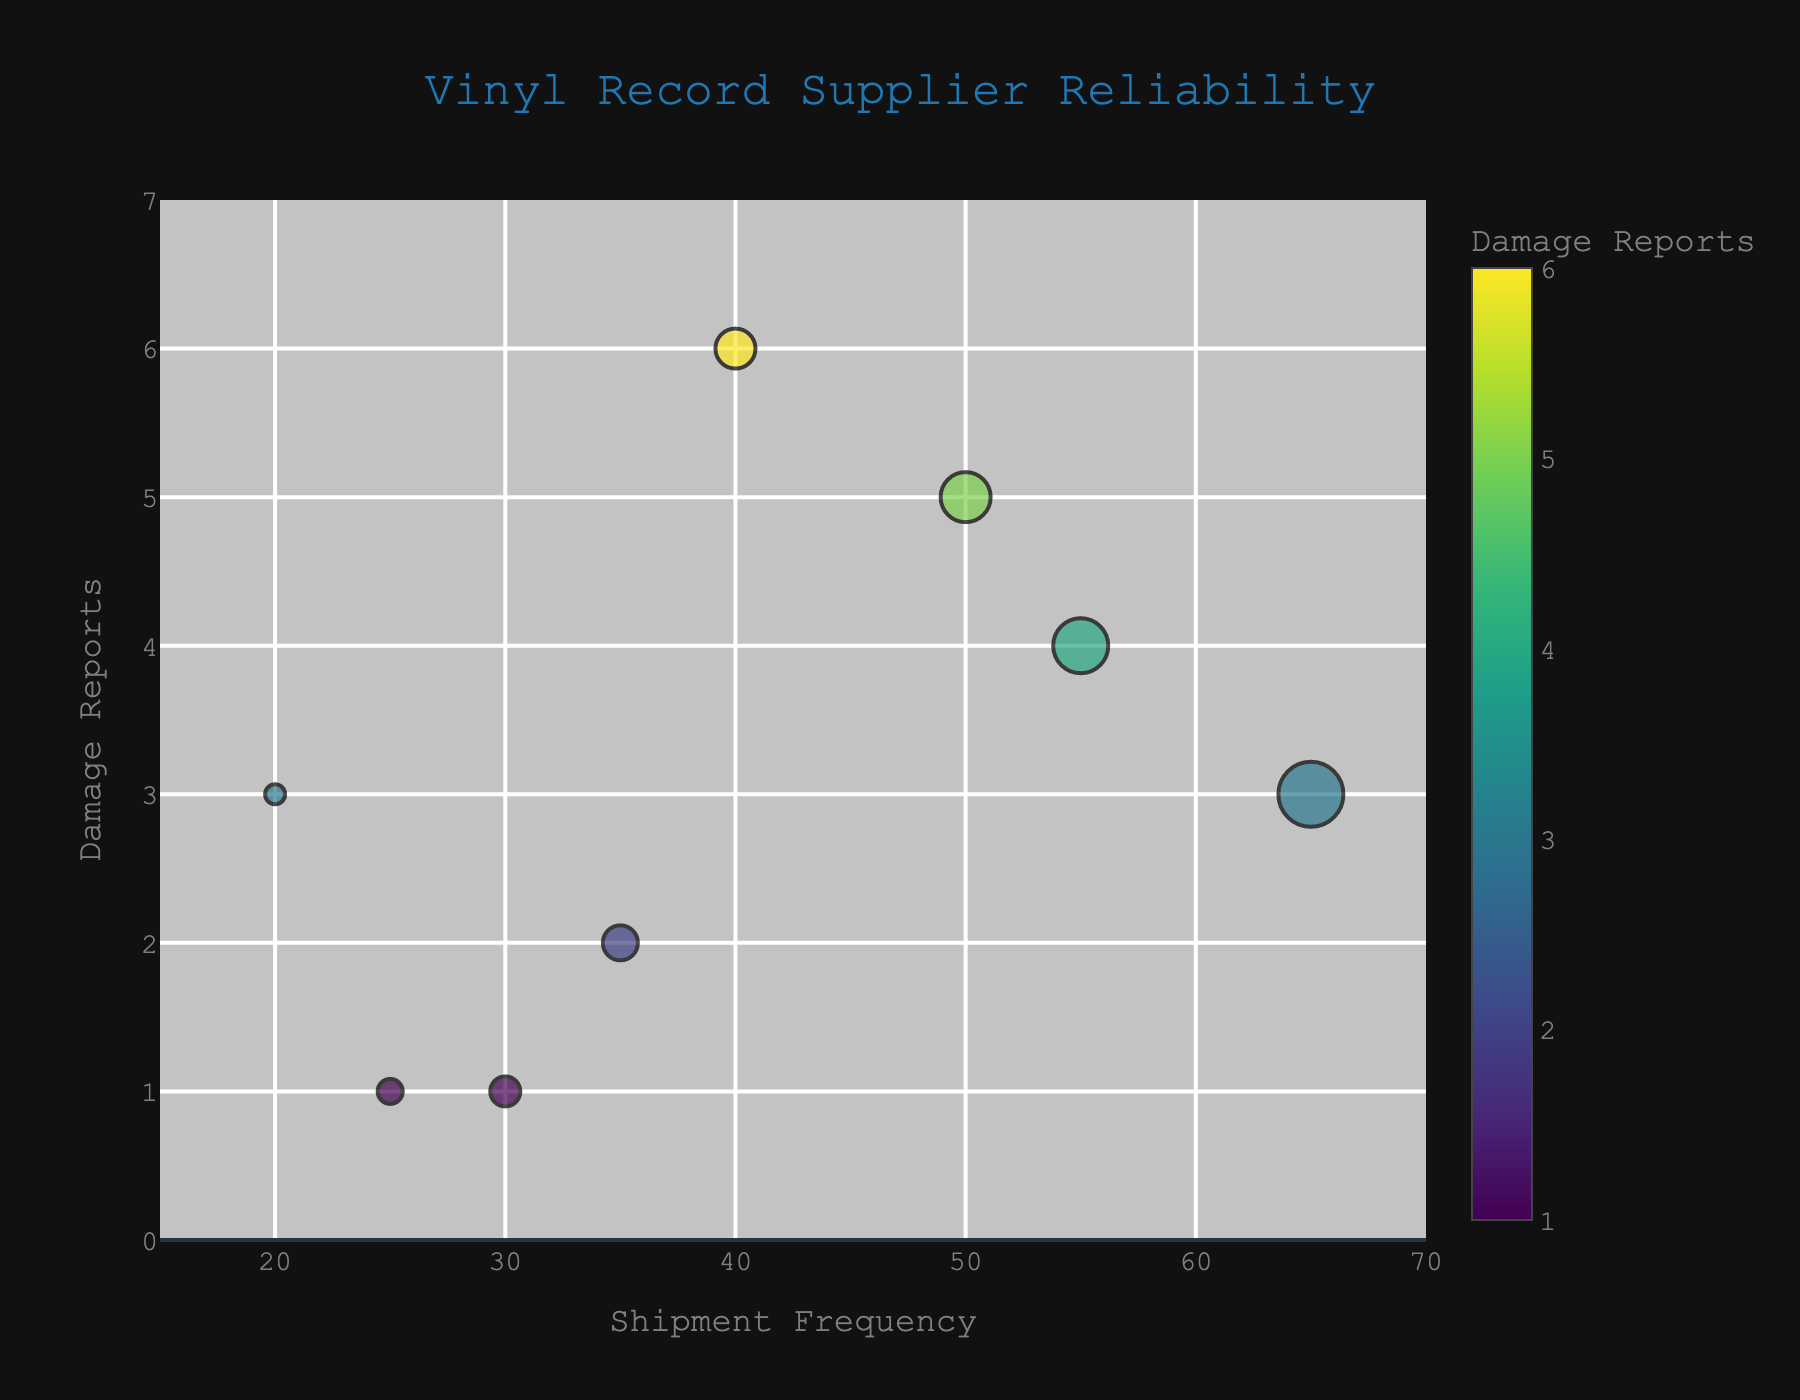Which supplier has the highest number of damage reports? Look for the data point that is highest on the Y-axis representing Damage Reports.
Answer: Beggar's Group Which supplier has the largest shipment frequency? Look for the data point that is furthest to the right on the X-axis representing Shipment Frequency.
Answer: Sony Music Entertainment Which supplier has the smallest shipment frequency and damage reports? Look for the data point that is at the lowest position on both X and Y axes.
Answer: Epitaph Records What is the title of the chart? Read the text at the top of the chart.
Answer: Vinyl Record Supplier Reliability How many suppliers reported exactly 1 damage? Count the data points that are at the Y-axis value of 1.
Answer: 2 Which supplier has a shipment frequency of 55? Look for the data point at X = 55 and check the supplier name in the hover text.
Answer: Warner Music Group Is there any supplier that has a shipment frequency of 30 and only 1 damage report? Check for a data point at (X, Y) = (30, 1) and confirm the supplier in hover text.
Answer: Concord Music Group How does Universal Music Group compare to Sony Music Entertainment in terms of damage reports? Locate the points for both suppliers and compare their Y-axis values. Universal Music Group has 5 damage reports and Sony Music Entertainment has 3.
Answer: Universal Music Group has more damage reports What is the range of shipment frequencies displayed on this chart? Check the minimum and maximum values on the X-axis.
Answer: 15 to 70 Which supplier, among Beggar's Group and Domino Recording Company, has higher shipment frequency? Compare the X-axis values of the points for both suppliers.
Answer: Beggar's Group 